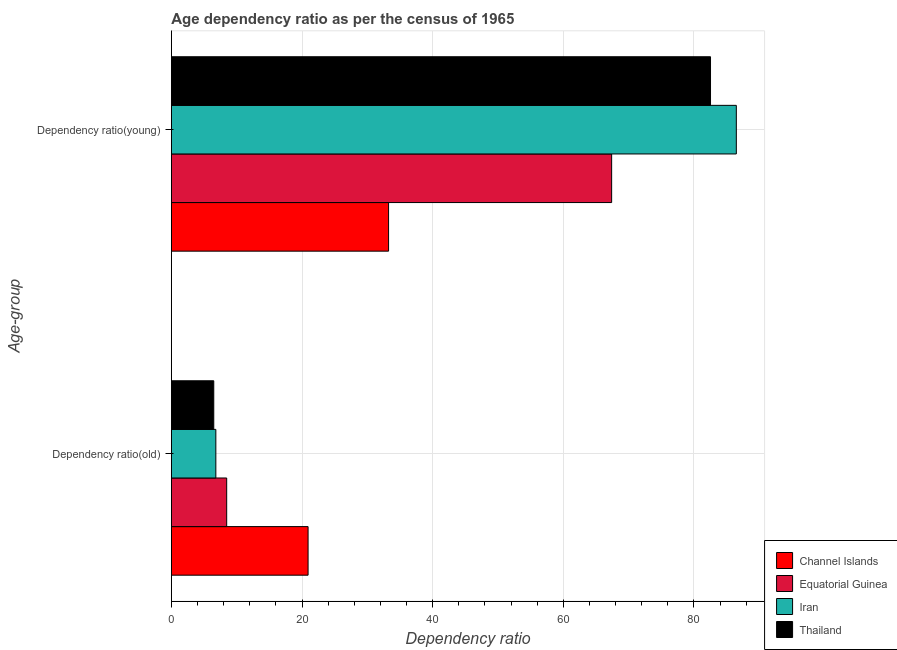How many different coloured bars are there?
Your answer should be very brief. 4. How many groups of bars are there?
Offer a very short reply. 2. Are the number of bars on each tick of the Y-axis equal?
Your answer should be compact. Yes. What is the label of the 2nd group of bars from the top?
Your answer should be very brief. Dependency ratio(old). What is the age dependency ratio(young) in Thailand?
Your answer should be compact. 82.53. Across all countries, what is the maximum age dependency ratio(old)?
Offer a very short reply. 20.93. Across all countries, what is the minimum age dependency ratio(young)?
Your response must be concise. 33.25. In which country was the age dependency ratio(old) maximum?
Ensure brevity in your answer.  Channel Islands. In which country was the age dependency ratio(young) minimum?
Ensure brevity in your answer.  Channel Islands. What is the total age dependency ratio(old) in the graph?
Your response must be concise. 42.69. What is the difference between the age dependency ratio(young) in Thailand and that in Channel Islands?
Your answer should be compact. 49.28. What is the difference between the age dependency ratio(old) in Equatorial Guinea and the age dependency ratio(young) in Iran?
Keep it short and to the point. -78.02. What is the average age dependency ratio(old) per country?
Offer a terse response. 10.67. What is the difference between the age dependency ratio(young) and age dependency ratio(old) in Channel Islands?
Your answer should be compact. 12.32. In how many countries, is the age dependency ratio(old) greater than 24 ?
Your answer should be very brief. 0. What is the ratio of the age dependency ratio(old) in Equatorial Guinea to that in Channel Islands?
Provide a succinct answer. 0.4. In how many countries, is the age dependency ratio(young) greater than the average age dependency ratio(young) taken over all countries?
Provide a short and direct response. 2. What does the 4th bar from the top in Dependency ratio(young) represents?
Offer a terse response. Channel Islands. What does the 3rd bar from the bottom in Dependency ratio(old) represents?
Your answer should be very brief. Iran. How many bars are there?
Offer a very short reply. 8. How many countries are there in the graph?
Provide a short and direct response. 4. What is the difference between two consecutive major ticks on the X-axis?
Ensure brevity in your answer.  20. Does the graph contain any zero values?
Provide a succinct answer. No. Does the graph contain grids?
Provide a succinct answer. Yes. Where does the legend appear in the graph?
Provide a succinct answer. Bottom right. What is the title of the graph?
Your answer should be compact. Age dependency ratio as per the census of 1965. What is the label or title of the X-axis?
Make the answer very short. Dependency ratio. What is the label or title of the Y-axis?
Provide a succinct answer. Age-group. What is the Dependency ratio in Channel Islands in Dependency ratio(old)?
Your answer should be very brief. 20.93. What is the Dependency ratio of Equatorial Guinea in Dependency ratio(old)?
Provide a short and direct response. 8.47. What is the Dependency ratio of Iran in Dependency ratio(old)?
Make the answer very short. 6.81. What is the Dependency ratio of Thailand in Dependency ratio(old)?
Your answer should be compact. 6.49. What is the Dependency ratio in Channel Islands in Dependency ratio(young)?
Give a very brief answer. 33.25. What is the Dependency ratio of Equatorial Guinea in Dependency ratio(young)?
Offer a very short reply. 67.4. What is the Dependency ratio in Iran in Dependency ratio(young)?
Make the answer very short. 86.48. What is the Dependency ratio of Thailand in Dependency ratio(young)?
Provide a succinct answer. 82.53. Across all Age-group, what is the maximum Dependency ratio in Channel Islands?
Your answer should be compact. 33.25. Across all Age-group, what is the maximum Dependency ratio of Equatorial Guinea?
Provide a short and direct response. 67.4. Across all Age-group, what is the maximum Dependency ratio in Iran?
Make the answer very short. 86.48. Across all Age-group, what is the maximum Dependency ratio of Thailand?
Offer a terse response. 82.53. Across all Age-group, what is the minimum Dependency ratio of Channel Islands?
Provide a succinct answer. 20.93. Across all Age-group, what is the minimum Dependency ratio in Equatorial Guinea?
Your response must be concise. 8.47. Across all Age-group, what is the minimum Dependency ratio in Iran?
Your answer should be compact. 6.81. Across all Age-group, what is the minimum Dependency ratio of Thailand?
Give a very brief answer. 6.49. What is the total Dependency ratio in Channel Islands in the graph?
Provide a succinct answer. 54.18. What is the total Dependency ratio of Equatorial Guinea in the graph?
Make the answer very short. 75.86. What is the total Dependency ratio of Iran in the graph?
Make the answer very short. 93.29. What is the total Dependency ratio in Thailand in the graph?
Your response must be concise. 89.02. What is the difference between the Dependency ratio in Channel Islands in Dependency ratio(old) and that in Dependency ratio(young)?
Keep it short and to the point. -12.32. What is the difference between the Dependency ratio in Equatorial Guinea in Dependency ratio(old) and that in Dependency ratio(young)?
Provide a short and direct response. -58.93. What is the difference between the Dependency ratio of Iran in Dependency ratio(old) and that in Dependency ratio(young)?
Offer a very short reply. -79.67. What is the difference between the Dependency ratio of Thailand in Dependency ratio(old) and that in Dependency ratio(young)?
Offer a terse response. -76.04. What is the difference between the Dependency ratio in Channel Islands in Dependency ratio(old) and the Dependency ratio in Equatorial Guinea in Dependency ratio(young)?
Your answer should be very brief. -46.47. What is the difference between the Dependency ratio in Channel Islands in Dependency ratio(old) and the Dependency ratio in Iran in Dependency ratio(young)?
Your answer should be compact. -65.56. What is the difference between the Dependency ratio in Channel Islands in Dependency ratio(old) and the Dependency ratio in Thailand in Dependency ratio(young)?
Give a very brief answer. -61.61. What is the difference between the Dependency ratio of Equatorial Guinea in Dependency ratio(old) and the Dependency ratio of Iran in Dependency ratio(young)?
Ensure brevity in your answer.  -78.02. What is the difference between the Dependency ratio in Equatorial Guinea in Dependency ratio(old) and the Dependency ratio in Thailand in Dependency ratio(young)?
Your answer should be compact. -74.07. What is the difference between the Dependency ratio in Iran in Dependency ratio(old) and the Dependency ratio in Thailand in Dependency ratio(young)?
Your answer should be compact. -75.72. What is the average Dependency ratio in Channel Islands per Age-group?
Your answer should be compact. 27.09. What is the average Dependency ratio in Equatorial Guinea per Age-group?
Offer a very short reply. 37.93. What is the average Dependency ratio in Iran per Age-group?
Make the answer very short. 46.64. What is the average Dependency ratio of Thailand per Age-group?
Make the answer very short. 44.51. What is the difference between the Dependency ratio in Channel Islands and Dependency ratio in Equatorial Guinea in Dependency ratio(old)?
Keep it short and to the point. 12.46. What is the difference between the Dependency ratio in Channel Islands and Dependency ratio in Iran in Dependency ratio(old)?
Your response must be concise. 14.12. What is the difference between the Dependency ratio in Channel Islands and Dependency ratio in Thailand in Dependency ratio(old)?
Ensure brevity in your answer.  14.44. What is the difference between the Dependency ratio of Equatorial Guinea and Dependency ratio of Iran in Dependency ratio(old)?
Your answer should be compact. 1.66. What is the difference between the Dependency ratio of Equatorial Guinea and Dependency ratio of Thailand in Dependency ratio(old)?
Provide a succinct answer. 1.98. What is the difference between the Dependency ratio of Iran and Dependency ratio of Thailand in Dependency ratio(old)?
Give a very brief answer. 0.32. What is the difference between the Dependency ratio of Channel Islands and Dependency ratio of Equatorial Guinea in Dependency ratio(young)?
Your response must be concise. -34.15. What is the difference between the Dependency ratio in Channel Islands and Dependency ratio in Iran in Dependency ratio(young)?
Provide a succinct answer. -53.23. What is the difference between the Dependency ratio in Channel Islands and Dependency ratio in Thailand in Dependency ratio(young)?
Your answer should be very brief. -49.28. What is the difference between the Dependency ratio of Equatorial Guinea and Dependency ratio of Iran in Dependency ratio(young)?
Your answer should be very brief. -19.09. What is the difference between the Dependency ratio of Equatorial Guinea and Dependency ratio of Thailand in Dependency ratio(young)?
Make the answer very short. -15.14. What is the difference between the Dependency ratio in Iran and Dependency ratio in Thailand in Dependency ratio(young)?
Offer a very short reply. 3.95. What is the ratio of the Dependency ratio in Channel Islands in Dependency ratio(old) to that in Dependency ratio(young)?
Keep it short and to the point. 0.63. What is the ratio of the Dependency ratio in Equatorial Guinea in Dependency ratio(old) to that in Dependency ratio(young)?
Your answer should be very brief. 0.13. What is the ratio of the Dependency ratio of Iran in Dependency ratio(old) to that in Dependency ratio(young)?
Make the answer very short. 0.08. What is the ratio of the Dependency ratio in Thailand in Dependency ratio(old) to that in Dependency ratio(young)?
Your answer should be very brief. 0.08. What is the difference between the highest and the second highest Dependency ratio of Channel Islands?
Your response must be concise. 12.32. What is the difference between the highest and the second highest Dependency ratio in Equatorial Guinea?
Your answer should be compact. 58.93. What is the difference between the highest and the second highest Dependency ratio of Iran?
Keep it short and to the point. 79.67. What is the difference between the highest and the second highest Dependency ratio of Thailand?
Ensure brevity in your answer.  76.04. What is the difference between the highest and the lowest Dependency ratio in Channel Islands?
Give a very brief answer. 12.32. What is the difference between the highest and the lowest Dependency ratio in Equatorial Guinea?
Your answer should be very brief. 58.93. What is the difference between the highest and the lowest Dependency ratio of Iran?
Ensure brevity in your answer.  79.67. What is the difference between the highest and the lowest Dependency ratio in Thailand?
Make the answer very short. 76.04. 